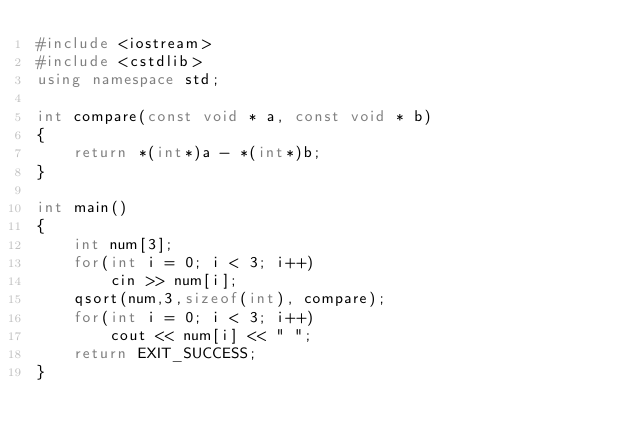Convert code to text. <code><loc_0><loc_0><loc_500><loc_500><_C++_>#include <iostream>
#include <cstdlib>
using namespace std;

int compare(const void * a, const void * b)
{
    return *(int*)a - *(int*)b;
}

int main()
{
    int num[3];
    for(int i = 0; i < 3; i++)
        cin >> num[i];
    qsort(num,3,sizeof(int), compare);
    for(int i = 0; i < 3; i++)
        cout << num[i] << " ";
    return EXIT_SUCCESS;
}</code> 